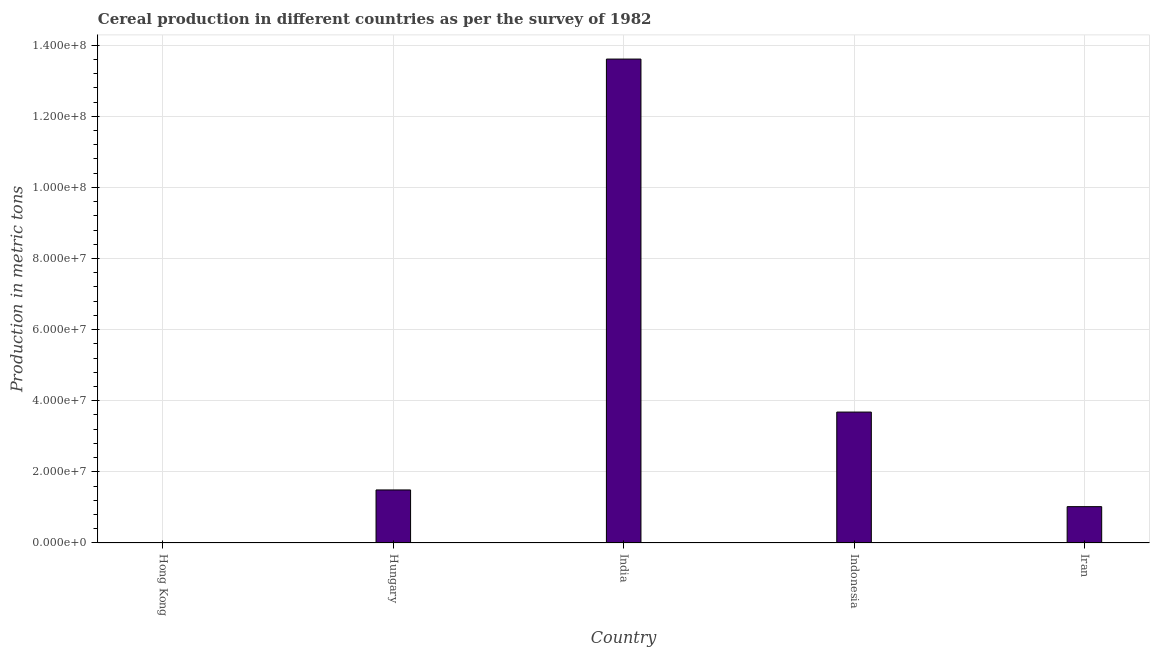Does the graph contain any zero values?
Make the answer very short. No. What is the title of the graph?
Ensure brevity in your answer.  Cereal production in different countries as per the survey of 1982. What is the label or title of the Y-axis?
Your answer should be compact. Production in metric tons. What is the cereal production in Indonesia?
Give a very brief answer. 3.68e+07. Across all countries, what is the maximum cereal production?
Your answer should be compact. 1.36e+08. Across all countries, what is the minimum cereal production?
Ensure brevity in your answer.  20. In which country was the cereal production maximum?
Your response must be concise. India. In which country was the cereal production minimum?
Provide a short and direct response. Hong Kong. What is the sum of the cereal production?
Keep it short and to the point. 1.98e+08. What is the difference between the cereal production in Hungary and Iran?
Make the answer very short. 4.70e+06. What is the average cereal production per country?
Provide a succinct answer. 3.96e+07. What is the median cereal production?
Your response must be concise. 1.49e+07. In how many countries, is the cereal production greater than 76000000 metric tons?
Offer a terse response. 1. What is the difference between the highest and the second highest cereal production?
Keep it short and to the point. 9.93e+07. What is the difference between the highest and the lowest cereal production?
Give a very brief answer. 1.36e+08. How many countries are there in the graph?
Provide a short and direct response. 5. What is the Production in metric tons in Hungary?
Keep it short and to the point. 1.49e+07. What is the Production in metric tons of India?
Provide a succinct answer. 1.36e+08. What is the Production in metric tons of Indonesia?
Your answer should be compact. 3.68e+07. What is the Production in metric tons of Iran?
Keep it short and to the point. 1.02e+07. What is the difference between the Production in metric tons in Hong Kong and Hungary?
Ensure brevity in your answer.  -1.49e+07. What is the difference between the Production in metric tons in Hong Kong and India?
Your response must be concise. -1.36e+08. What is the difference between the Production in metric tons in Hong Kong and Indonesia?
Make the answer very short. -3.68e+07. What is the difference between the Production in metric tons in Hong Kong and Iran?
Offer a terse response. -1.02e+07. What is the difference between the Production in metric tons in Hungary and India?
Provide a succinct answer. -1.21e+08. What is the difference between the Production in metric tons in Hungary and Indonesia?
Offer a terse response. -2.19e+07. What is the difference between the Production in metric tons in Hungary and Iran?
Ensure brevity in your answer.  4.70e+06. What is the difference between the Production in metric tons in India and Indonesia?
Ensure brevity in your answer.  9.93e+07. What is the difference between the Production in metric tons in India and Iran?
Provide a succinct answer. 1.26e+08. What is the difference between the Production in metric tons in Indonesia and Iran?
Provide a short and direct response. 2.66e+07. What is the ratio of the Production in metric tons in Hong Kong to that in Hungary?
Provide a short and direct response. 0. What is the ratio of the Production in metric tons in Hong Kong to that in India?
Provide a succinct answer. 0. What is the ratio of the Production in metric tons in Hungary to that in India?
Provide a short and direct response. 0.11. What is the ratio of the Production in metric tons in Hungary to that in Indonesia?
Your response must be concise. 0.41. What is the ratio of the Production in metric tons in Hungary to that in Iran?
Keep it short and to the point. 1.46. What is the ratio of the Production in metric tons in India to that in Indonesia?
Provide a succinct answer. 3.7. What is the ratio of the Production in metric tons in India to that in Iran?
Offer a very short reply. 13.31. What is the ratio of the Production in metric tons in Indonesia to that in Iran?
Provide a short and direct response. 3.6. 